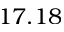Convert formula to latex. <formula><loc_0><loc_0><loc_500><loc_500>1 7 . 1 8</formula> 